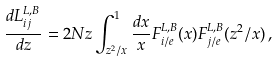<formula> <loc_0><loc_0><loc_500><loc_500>\frac { d L _ { i j } ^ { L , B } } { d z } = 2 N z \int _ { z ^ { 2 } / x } ^ { 1 } \frac { d x } { x } F _ { i / e } ^ { L , B } ( x ) F _ { j / e } ^ { L , B } ( z ^ { 2 } / x ) \, ,</formula> 